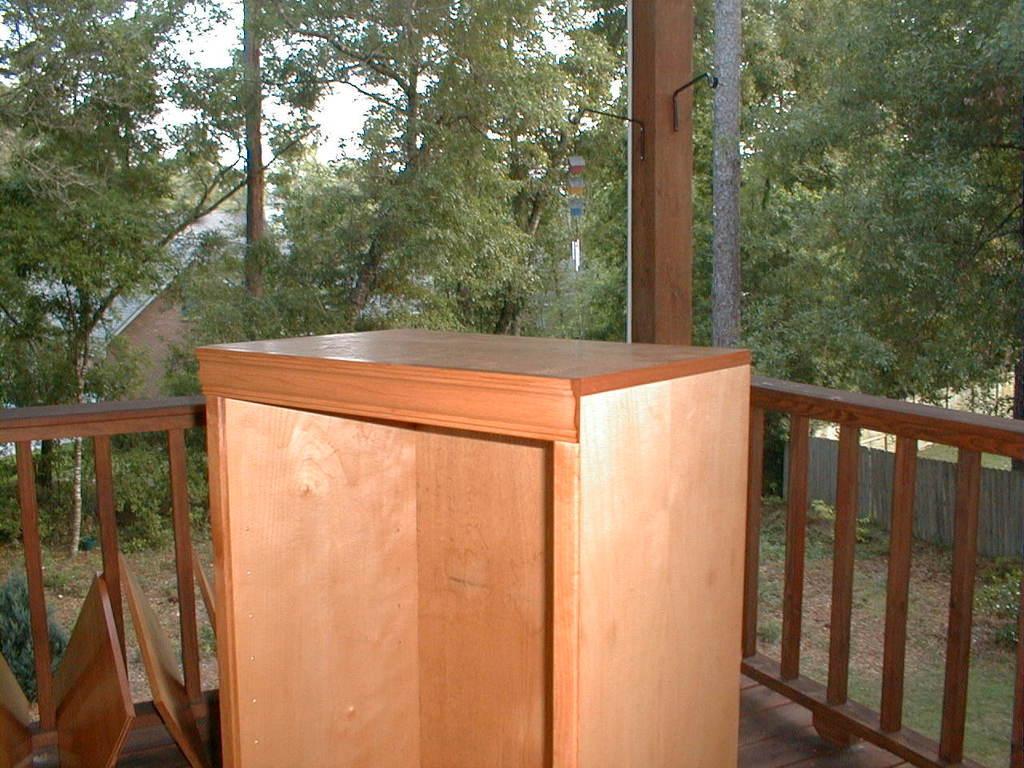Can you describe this image briefly? Here I can see a podium, behind this there is a wooden railing. On the left side there are few wooden plank. In the background there are many trees and also I can see a house. At the top of the image I can see the sky. On the right side there is a fencing and I can see the plants and grass on the ground. 